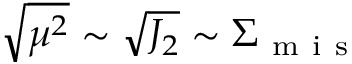Convert formula to latex. <formula><loc_0><loc_0><loc_500><loc_500>\sqrt { \mu ^ { 2 } } \sim \sqrt { J _ { 2 } } \sim \Sigma _ { m i s }</formula> 